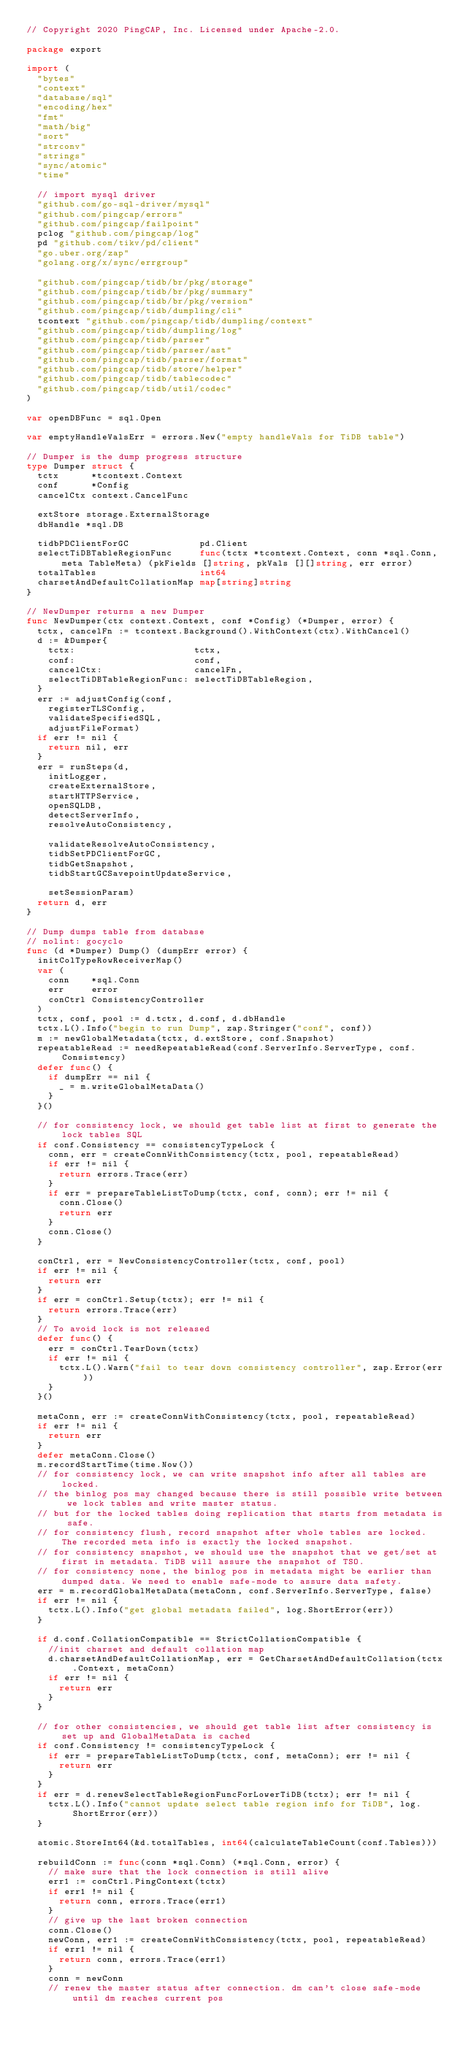Convert code to text. <code><loc_0><loc_0><loc_500><loc_500><_Go_>// Copyright 2020 PingCAP, Inc. Licensed under Apache-2.0.

package export

import (
	"bytes"
	"context"
	"database/sql"
	"encoding/hex"
	"fmt"
	"math/big"
	"sort"
	"strconv"
	"strings"
	"sync/atomic"
	"time"

	// import mysql driver
	"github.com/go-sql-driver/mysql"
	"github.com/pingcap/errors"
	"github.com/pingcap/failpoint"
	pclog "github.com/pingcap/log"
	pd "github.com/tikv/pd/client"
	"go.uber.org/zap"
	"golang.org/x/sync/errgroup"

	"github.com/pingcap/tidb/br/pkg/storage"
	"github.com/pingcap/tidb/br/pkg/summary"
	"github.com/pingcap/tidb/br/pkg/version"
	"github.com/pingcap/tidb/dumpling/cli"
	tcontext "github.com/pingcap/tidb/dumpling/context"
	"github.com/pingcap/tidb/dumpling/log"
	"github.com/pingcap/tidb/parser"
	"github.com/pingcap/tidb/parser/ast"
	"github.com/pingcap/tidb/parser/format"
	"github.com/pingcap/tidb/store/helper"
	"github.com/pingcap/tidb/tablecodec"
	"github.com/pingcap/tidb/util/codec"
)

var openDBFunc = sql.Open

var emptyHandleValsErr = errors.New("empty handleVals for TiDB table")

// Dumper is the dump progress structure
type Dumper struct {
	tctx      *tcontext.Context
	conf      *Config
	cancelCtx context.CancelFunc

	extStore storage.ExternalStorage
	dbHandle *sql.DB

	tidbPDClientForGC             pd.Client
	selectTiDBTableRegionFunc     func(tctx *tcontext.Context, conn *sql.Conn, meta TableMeta) (pkFields []string, pkVals [][]string, err error)
	totalTables                   int64
	charsetAndDefaultCollationMap map[string]string
}

// NewDumper returns a new Dumper
func NewDumper(ctx context.Context, conf *Config) (*Dumper, error) {
	tctx, cancelFn := tcontext.Background().WithContext(ctx).WithCancel()
	d := &Dumper{
		tctx:                      tctx,
		conf:                      conf,
		cancelCtx:                 cancelFn,
		selectTiDBTableRegionFunc: selectTiDBTableRegion,
	}
	err := adjustConfig(conf,
		registerTLSConfig,
		validateSpecifiedSQL,
		adjustFileFormat)
	if err != nil {
		return nil, err
	}
	err = runSteps(d,
		initLogger,
		createExternalStore,
		startHTTPService,
		openSQLDB,
		detectServerInfo,
		resolveAutoConsistency,

		validateResolveAutoConsistency,
		tidbSetPDClientForGC,
		tidbGetSnapshot,
		tidbStartGCSavepointUpdateService,

		setSessionParam)
	return d, err
}

// Dump dumps table from database
// nolint: gocyclo
func (d *Dumper) Dump() (dumpErr error) {
	initColTypeRowReceiverMap()
	var (
		conn    *sql.Conn
		err     error
		conCtrl ConsistencyController
	)
	tctx, conf, pool := d.tctx, d.conf, d.dbHandle
	tctx.L().Info("begin to run Dump", zap.Stringer("conf", conf))
	m := newGlobalMetadata(tctx, d.extStore, conf.Snapshot)
	repeatableRead := needRepeatableRead(conf.ServerInfo.ServerType, conf.Consistency)
	defer func() {
		if dumpErr == nil {
			_ = m.writeGlobalMetaData()
		}
	}()

	// for consistency lock, we should get table list at first to generate the lock tables SQL
	if conf.Consistency == consistencyTypeLock {
		conn, err = createConnWithConsistency(tctx, pool, repeatableRead)
		if err != nil {
			return errors.Trace(err)
		}
		if err = prepareTableListToDump(tctx, conf, conn); err != nil {
			conn.Close()
			return err
		}
		conn.Close()
	}

	conCtrl, err = NewConsistencyController(tctx, conf, pool)
	if err != nil {
		return err
	}
	if err = conCtrl.Setup(tctx); err != nil {
		return errors.Trace(err)
	}
	// To avoid lock is not released
	defer func() {
		err = conCtrl.TearDown(tctx)
		if err != nil {
			tctx.L().Warn("fail to tear down consistency controller", zap.Error(err))
		}
	}()

	metaConn, err := createConnWithConsistency(tctx, pool, repeatableRead)
	if err != nil {
		return err
	}
	defer metaConn.Close()
	m.recordStartTime(time.Now())
	// for consistency lock, we can write snapshot info after all tables are locked.
	// the binlog pos may changed because there is still possible write between we lock tables and write master status.
	// but for the locked tables doing replication that starts from metadata is safe.
	// for consistency flush, record snapshot after whole tables are locked. The recorded meta info is exactly the locked snapshot.
	// for consistency snapshot, we should use the snapshot that we get/set at first in metadata. TiDB will assure the snapshot of TSO.
	// for consistency none, the binlog pos in metadata might be earlier than dumped data. We need to enable safe-mode to assure data safety.
	err = m.recordGlobalMetaData(metaConn, conf.ServerInfo.ServerType, false)
	if err != nil {
		tctx.L().Info("get global metadata failed", log.ShortError(err))
	}

	if d.conf.CollationCompatible == StrictCollationCompatible {
		//init charset and default collation map
		d.charsetAndDefaultCollationMap, err = GetCharsetAndDefaultCollation(tctx.Context, metaConn)
		if err != nil {
			return err
		}
	}

	// for other consistencies, we should get table list after consistency is set up and GlobalMetaData is cached
	if conf.Consistency != consistencyTypeLock {
		if err = prepareTableListToDump(tctx, conf, metaConn); err != nil {
			return err
		}
	}
	if err = d.renewSelectTableRegionFuncForLowerTiDB(tctx); err != nil {
		tctx.L().Info("cannot update select table region info for TiDB", log.ShortError(err))
	}

	atomic.StoreInt64(&d.totalTables, int64(calculateTableCount(conf.Tables)))

	rebuildConn := func(conn *sql.Conn) (*sql.Conn, error) {
		// make sure that the lock connection is still alive
		err1 := conCtrl.PingContext(tctx)
		if err1 != nil {
			return conn, errors.Trace(err1)
		}
		// give up the last broken connection
		conn.Close()
		newConn, err1 := createConnWithConsistency(tctx, pool, repeatableRead)
		if err1 != nil {
			return conn, errors.Trace(err1)
		}
		conn = newConn
		// renew the master status after connection. dm can't close safe-mode until dm reaches current pos</code> 